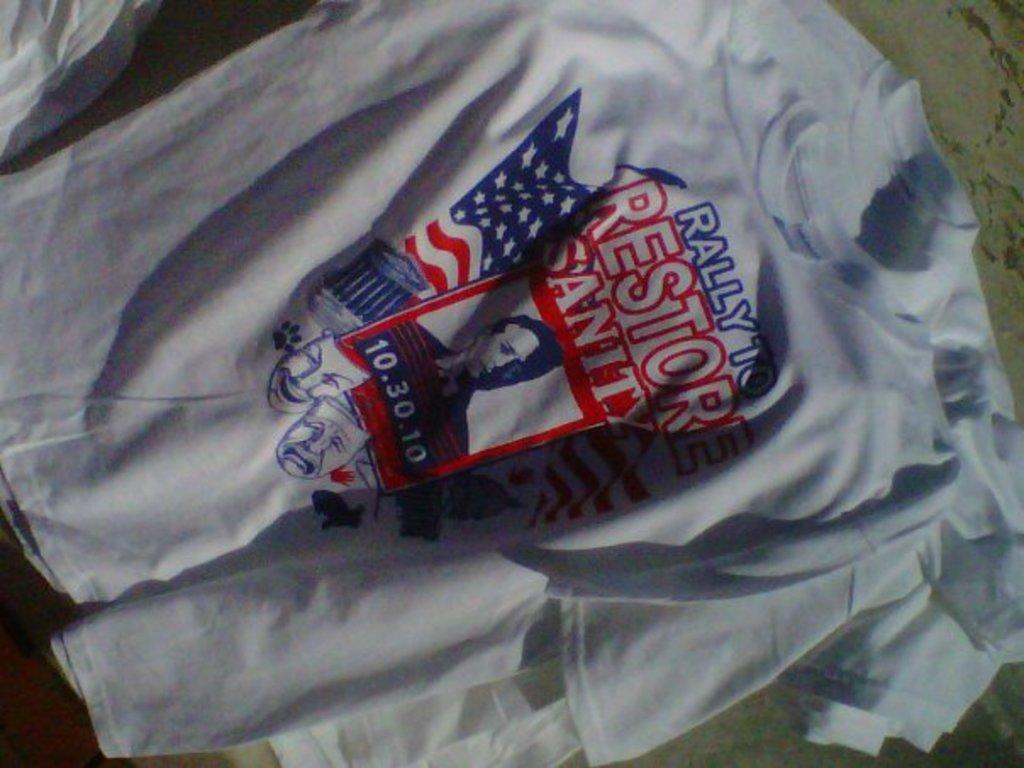On what date did the rally occur?
Ensure brevity in your answer.  10.30.10. What was the purpose of the rally?
Give a very brief answer. Restore sanity. 